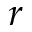Convert formula to latex. <formula><loc_0><loc_0><loc_500><loc_500>r</formula> 